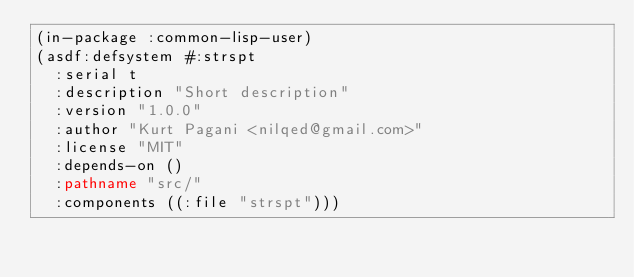Convert code to text. <code><loc_0><loc_0><loc_500><loc_500><_Lisp_>(in-package :common-lisp-user)
(asdf:defsystem #:strspt
  :serial t
  :description "Short description"
  :version "1.0.0"
  :author "Kurt Pagani <nilqed@gmail.com>"
  :license "MIT"
  :depends-on ()
  :pathname "src/"
  :components ((:file "strspt")))
</code> 